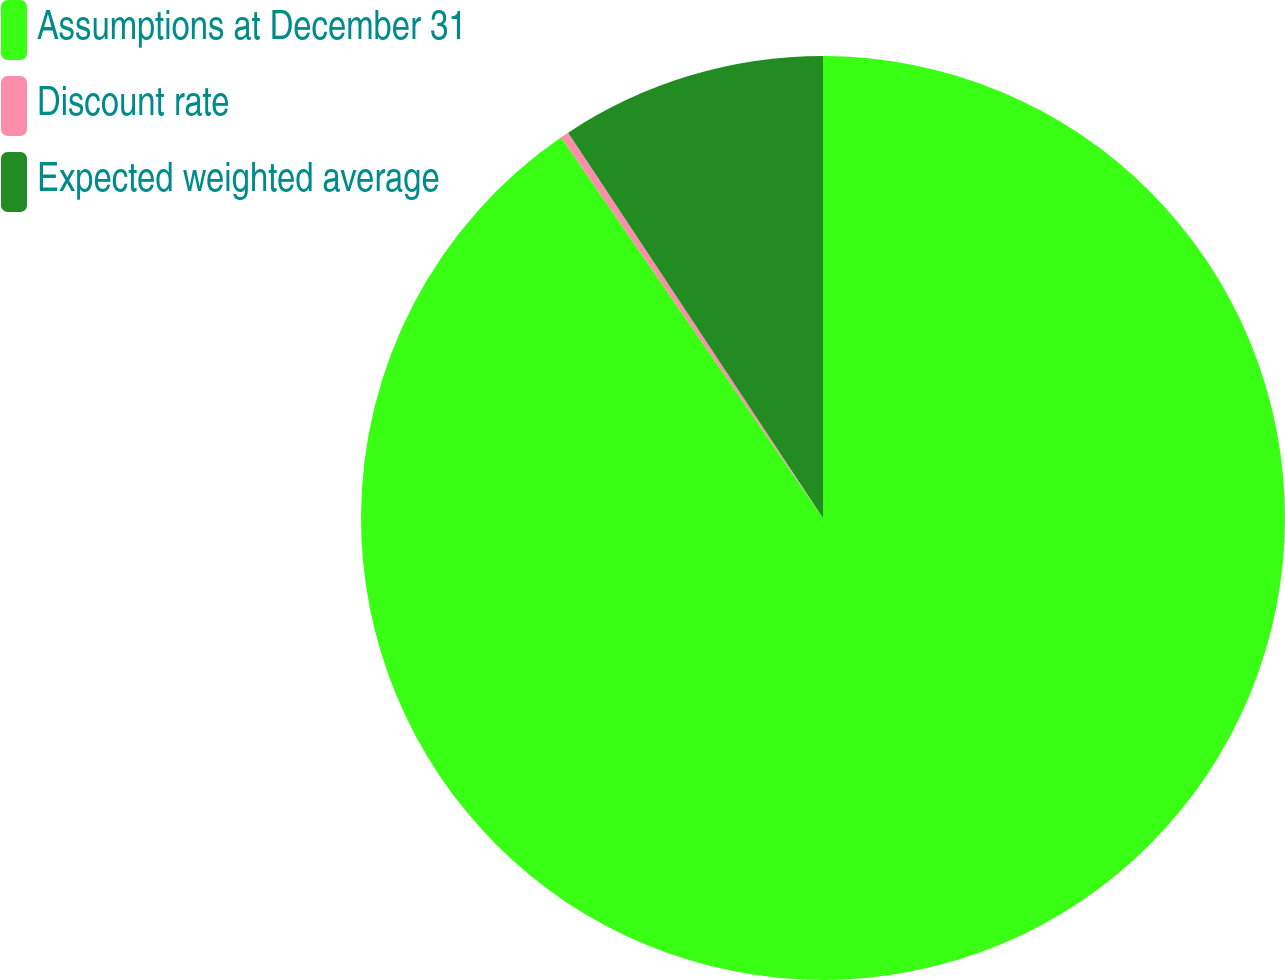<chart> <loc_0><loc_0><loc_500><loc_500><pie_chart><fcel>Assumptions at December 31<fcel>Discount rate<fcel>Expected weighted average<nl><fcel>90.42%<fcel>0.29%<fcel>9.3%<nl></chart> 